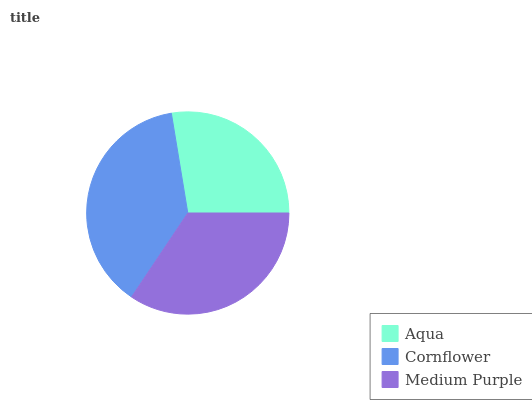Is Aqua the minimum?
Answer yes or no. Yes. Is Cornflower the maximum?
Answer yes or no. Yes. Is Medium Purple the minimum?
Answer yes or no. No. Is Medium Purple the maximum?
Answer yes or no. No. Is Cornflower greater than Medium Purple?
Answer yes or no. Yes. Is Medium Purple less than Cornflower?
Answer yes or no. Yes. Is Medium Purple greater than Cornflower?
Answer yes or no. No. Is Cornflower less than Medium Purple?
Answer yes or no. No. Is Medium Purple the high median?
Answer yes or no. Yes. Is Medium Purple the low median?
Answer yes or no. Yes. Is Aqua the high median?
Answer yes or no. No. Is Aqua the low median?
Answer yes or no. No. 